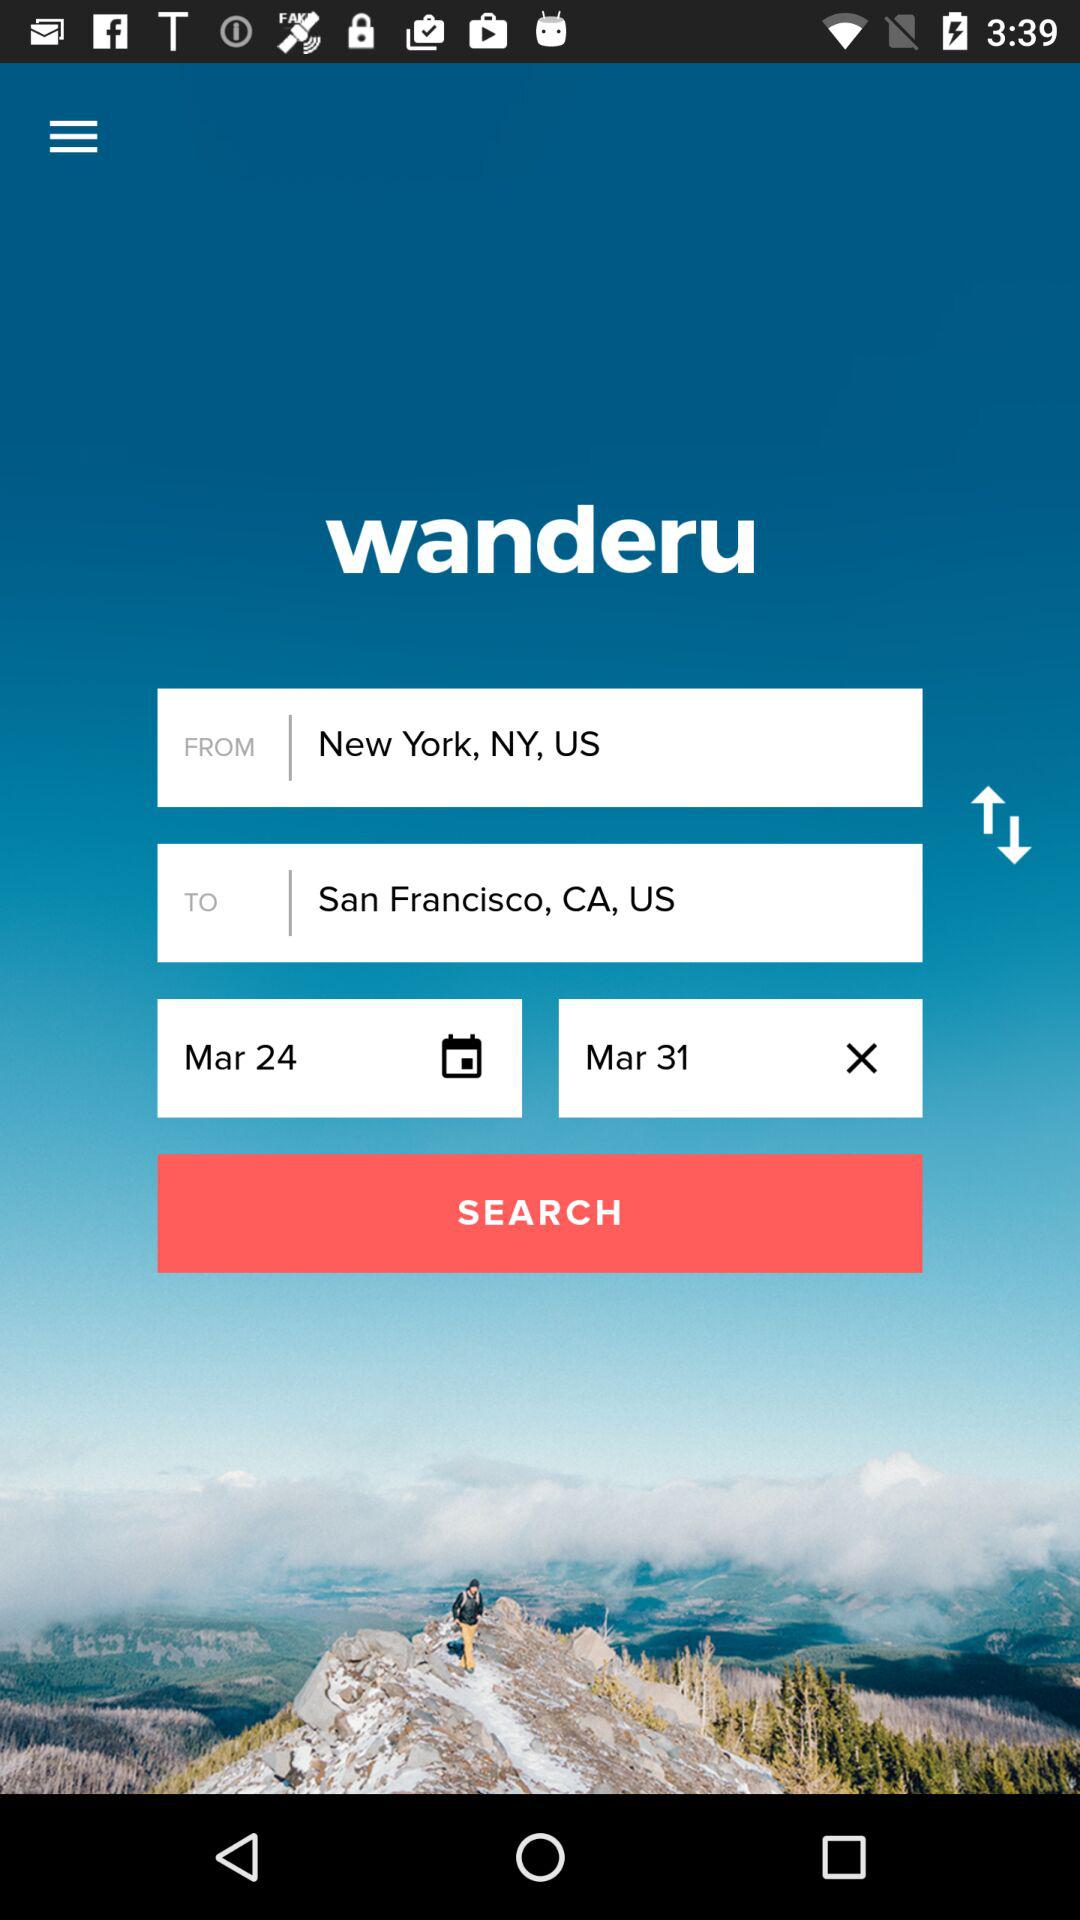What is the name of the application? The name of the application is "wanderu". 